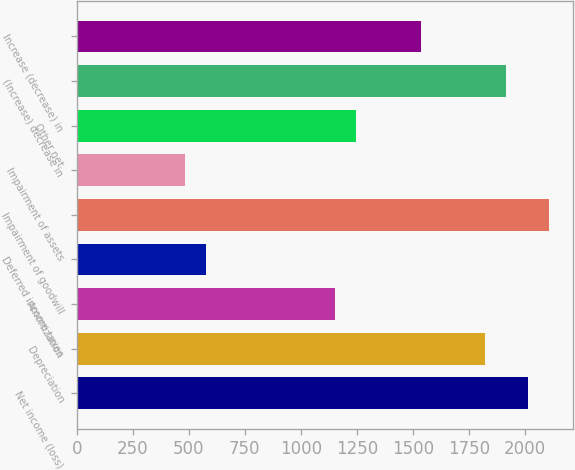Convert chart to OTSL. <chart><loc_0><loc_0><loc_500><loc_500><bar_chart><fcel>Net income (loss)<fcel>Depreciation<fcel>Amortization<fcel>Deferred income taxes<fcel>Impairment of goodwill<fcel>Impairment of assets<fcel>Other net<fcel>(Increase) decrease in<fcel>Increase (decrease) in<nl><fcel>2013.83<fcel>1822.23<fcel>1151.63<fcel>576.83<fcel>2109.63<fcel>481.03<fcel>1247.43<fcel>1918.03<fcel>1534.83<nl></chart> 